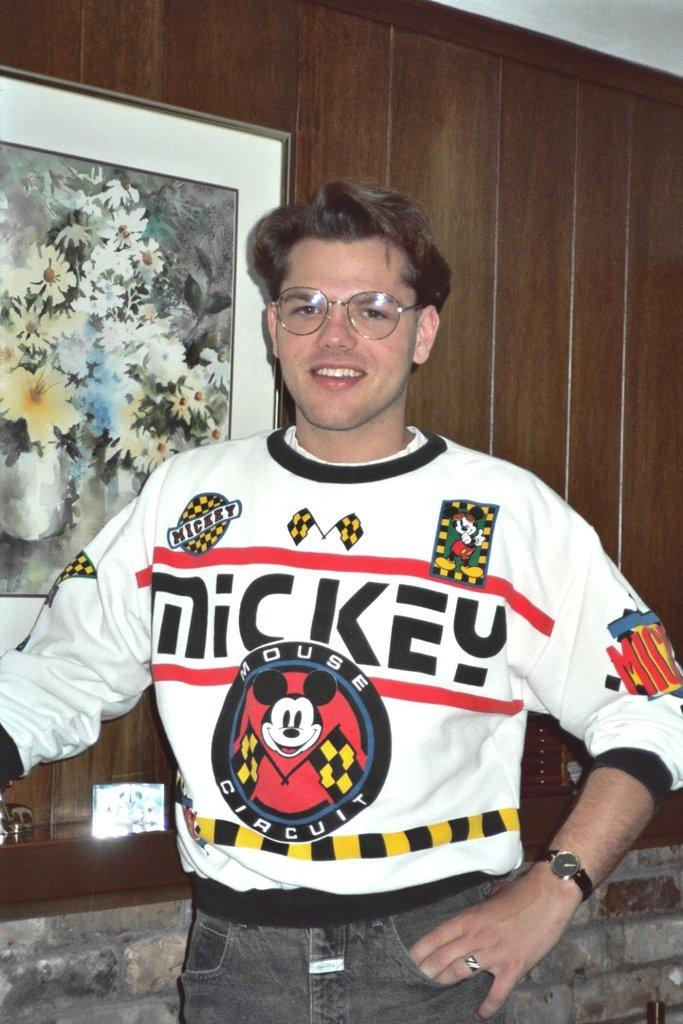<image>
Relay a brief, clear account of the picture shown. A person in a Mickey Mouse circuit shirt smiles at the camera. 